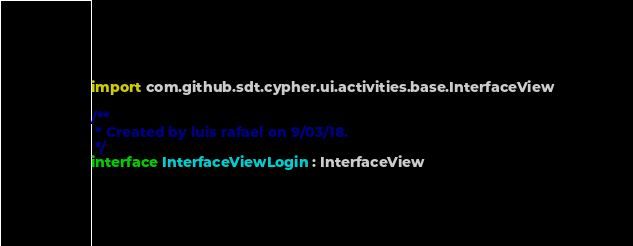Convert code to text. <code><loc_0><loc_0><loc_500><loc_500><_Kotlin_>
import com.github.sdt.cypher.ui.activities.base.InterfaceView

/**
 * Created by luis rafael on 9/03/18.
 */
interface InterfaceViewLogin : InterfaceView</code> 